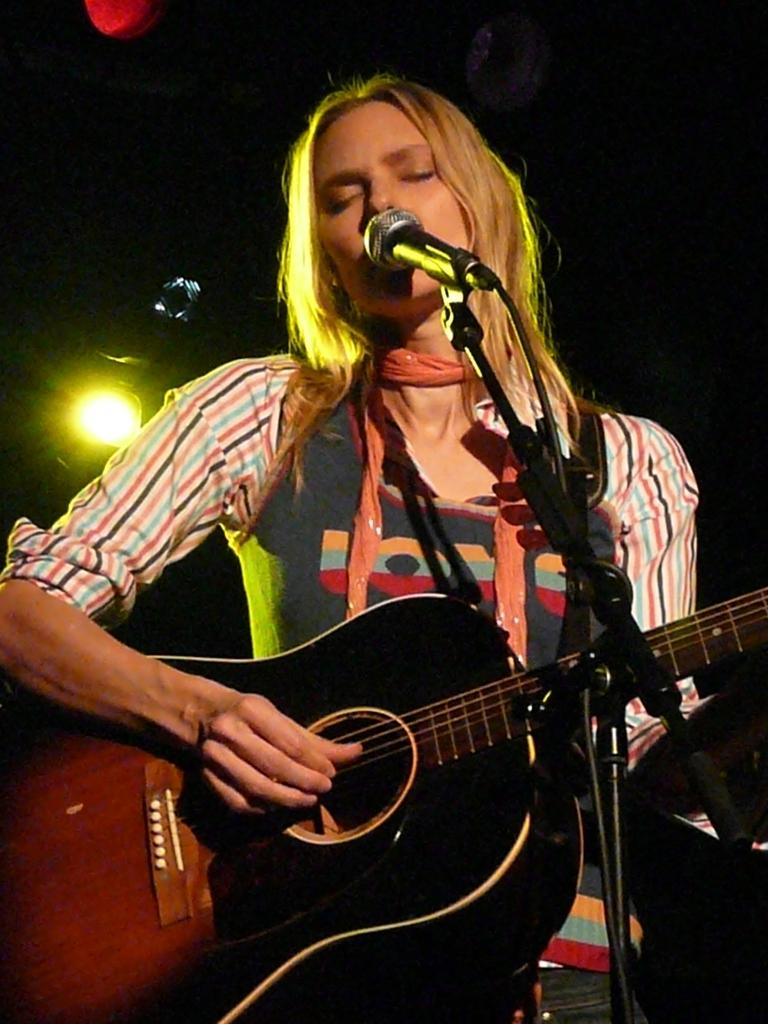Who is the main subject in the image? There is a woman in the image. What is the woman doing in the image? The woman is standing, playing a guitar, and singing on a microphone. What can be seen behind the woman in the image? There are lights visible behind the woman. What is the woman wearing in the image? The woman is wearing a scarf. What type of bomb can be seen in the image? There is no bomb present in the image. Is the woman melting any wax in the image? There is no wax or any indication of melting in the image. 